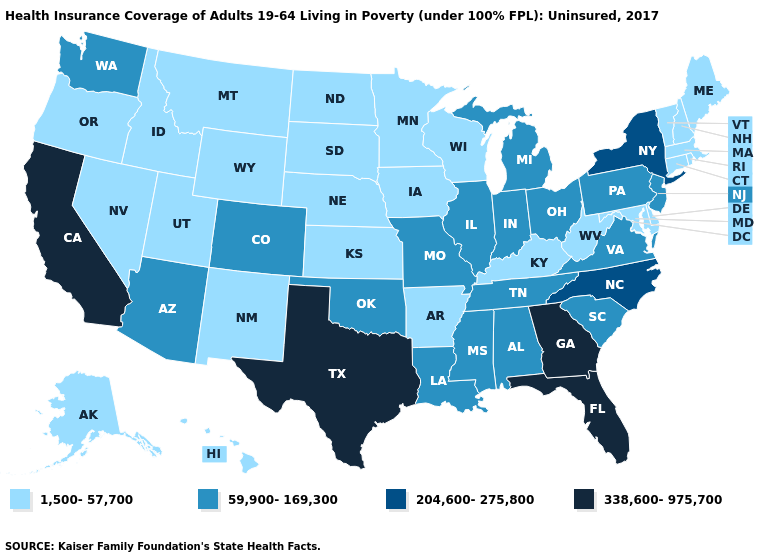Among the states that border Illinois , does Wisconsin have the highest value?
Be succinct. No. What is the highest value in states that border Kansas?
Write a very short answer. 59,900-169,300. Name the states that have a value in the range 59,900-169,300?
Answer briefly. Alabama, Arizona, Colorado, Illinois, Indiana, Louisiana, Michigan, Mississippi, Missouri, New Jersey, Ohio, Oklahoma, Pennsylvania, South Carolina, Tennessee, Virginia, Washington. What is the lowest value in the USA?
Quick response, please. 1,500-57,700. What is the value of Illinois?
Concise answer only. 59,900-169,300. What is the highest value in the USA?
Keep it brief. 338,600-975,700. What is the highest value in the MidWest ?
Concise answer only. 59,900-169,300. What is the value of Maine?
Short answer required. 1,500-57,700. What is the lowest value in the USA?
Short answer required. 1,500-57,700. Name the states that have a value in the range 338,600-975,700?
Short answer required. California, Florida, Georgia, Texas. What is the value of Alaska?
Quick response, please. 1,500-57,700. Is the legend a continuous bar?
Be succinct. No. What is the value of Wisconsin?
Give a very brief answer. 1,500-57,700. What is the lowest value in the USA?
Concise answer only. 1,500-57,700. 